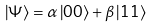<formula> <loc_0><loc_0><loc_500><loc_500>\left | \Psi \right \rangle = \alpha \left | 0 0 \right \rangle + \beta \left | 1 1 \right \rangle</formula> 